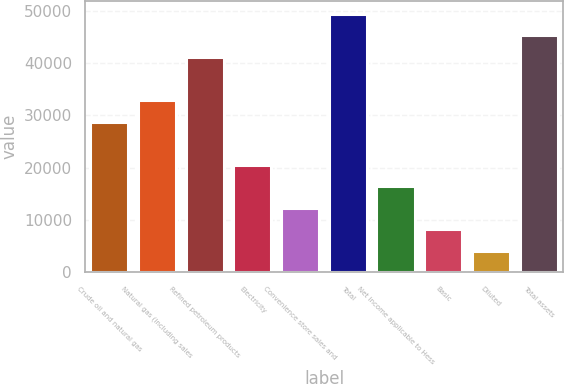Convert chart to OTSL. <chart><loc_0><loc_0><loc_500><loc_500><bar_chart><fcel>Crude oil and natural gas<fcel>Natural gas (including sales<fcel>Refined petroleum products<fcel>Electricity<fcel>Convenience store sales and<fcel>Total<fcel>Net income applicable to Hess<fcel>Basic<fcel>Diluted<fcel>Total assets<nl><fcel>28793.9<fcel>32907.3<fcel>41134<fcel>20567.2<fcel>12340.5<fcel>49360.7<fcel>16453.8<fcel>8227.12<fcel>4113.76<fcel>45247.4<nl></chart> 